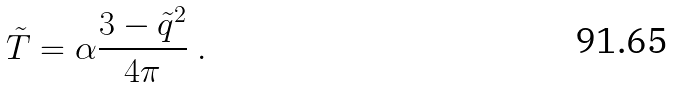Convert formula to latex. <formula><loc_0><loc_0><loc_500><loc_500>\tilde { T } = \alpha \frac { 3 - \tilde { q } ^ { 2 } } { 4 \pi } \ .</formula> 